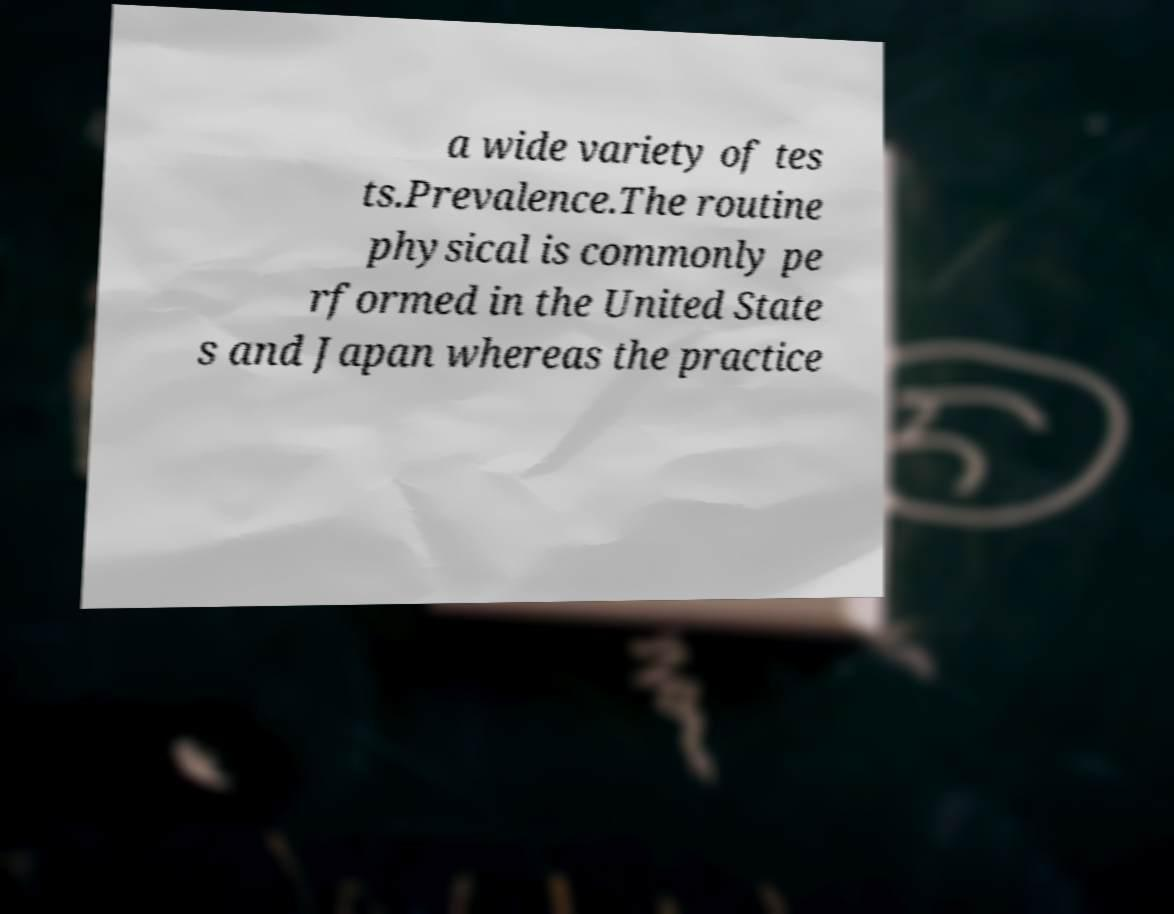Please read and relay the text visible in this image. What does it say? a wide variety of tes ts.Prevalence.The routine physical is commonly pe rformed in the United State s and Japan whereas the practice 